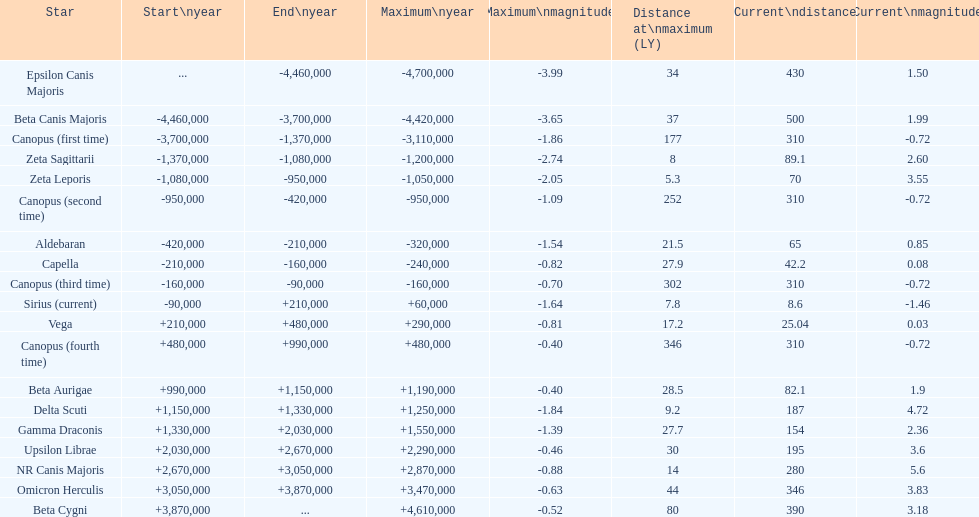What is the difference in light-years between epsilon canis majoris and zeta sagittarii? 26. 